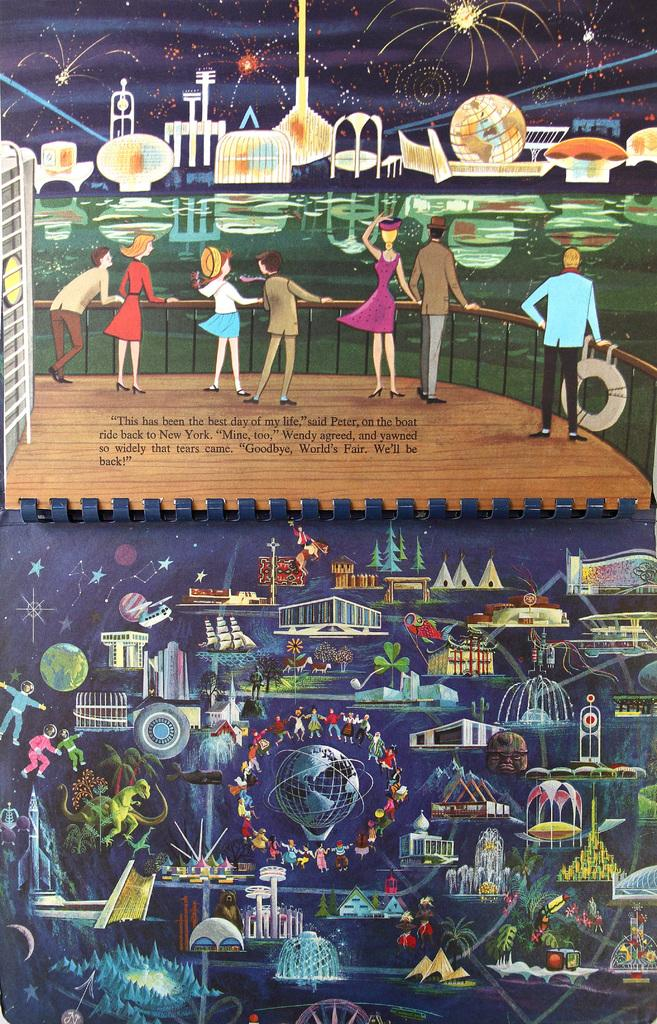<image>
Give a short and clear explanation of the subsequent image. a series of cartoon characters with the city of New York mentioned 